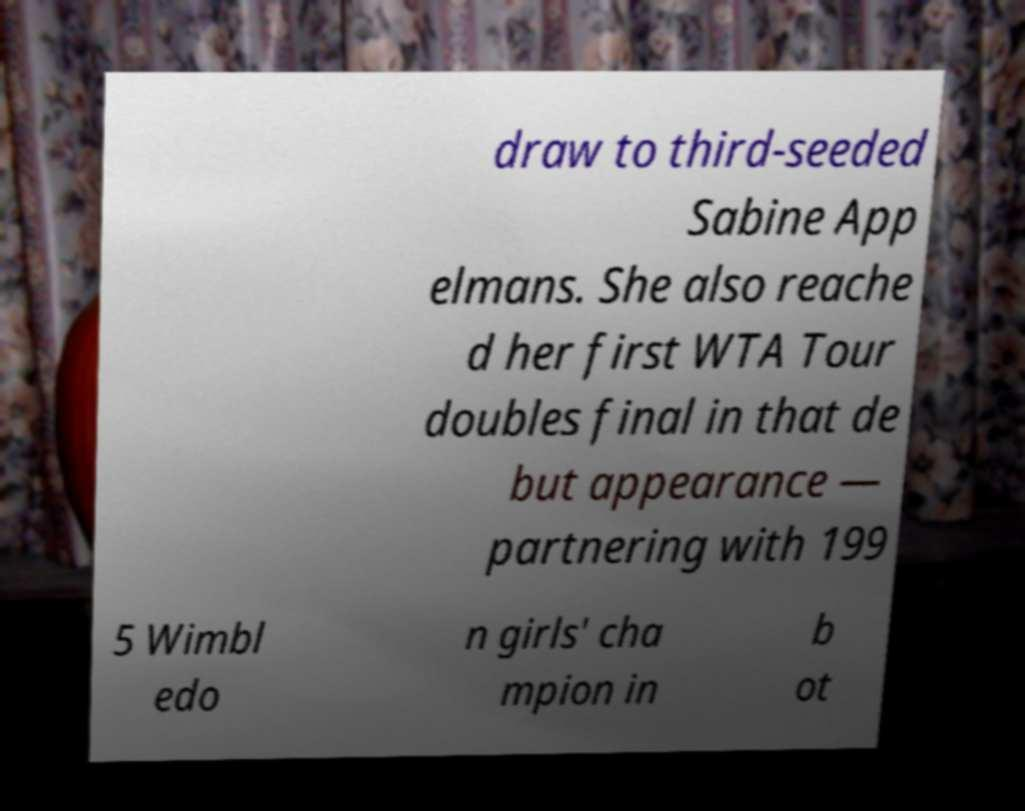Can you accurately transcribe the text from the provided image for me? draw to third-seeded Sabine App elmans. She also reache d her first WTA Tour doubles final in that de but appearance — partnering with 199 5 Wimbl edo n girls' cha mpion in b ot 